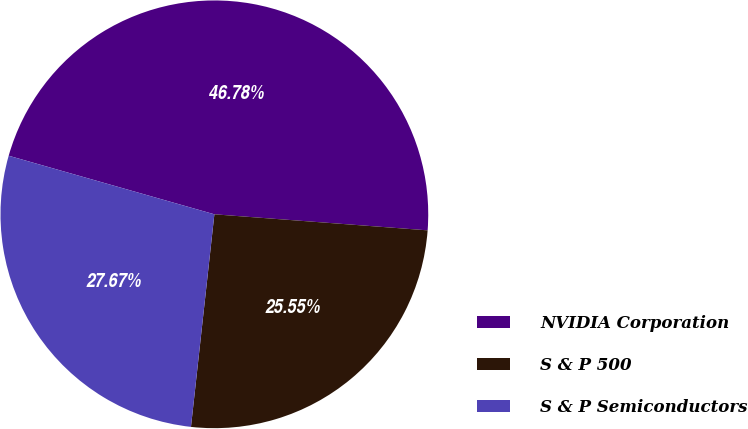Convert chart to OTSL. <chart><loc_0><loc_0><loc_500><loc_500><pie_chart><fcel>NVIDIA Corporation<fcel>S & P 500<fcel>S & P Semiconductors<nl><fcel>46.78%<fcel>25.55%<fcel>27.67%<nl></chart> 